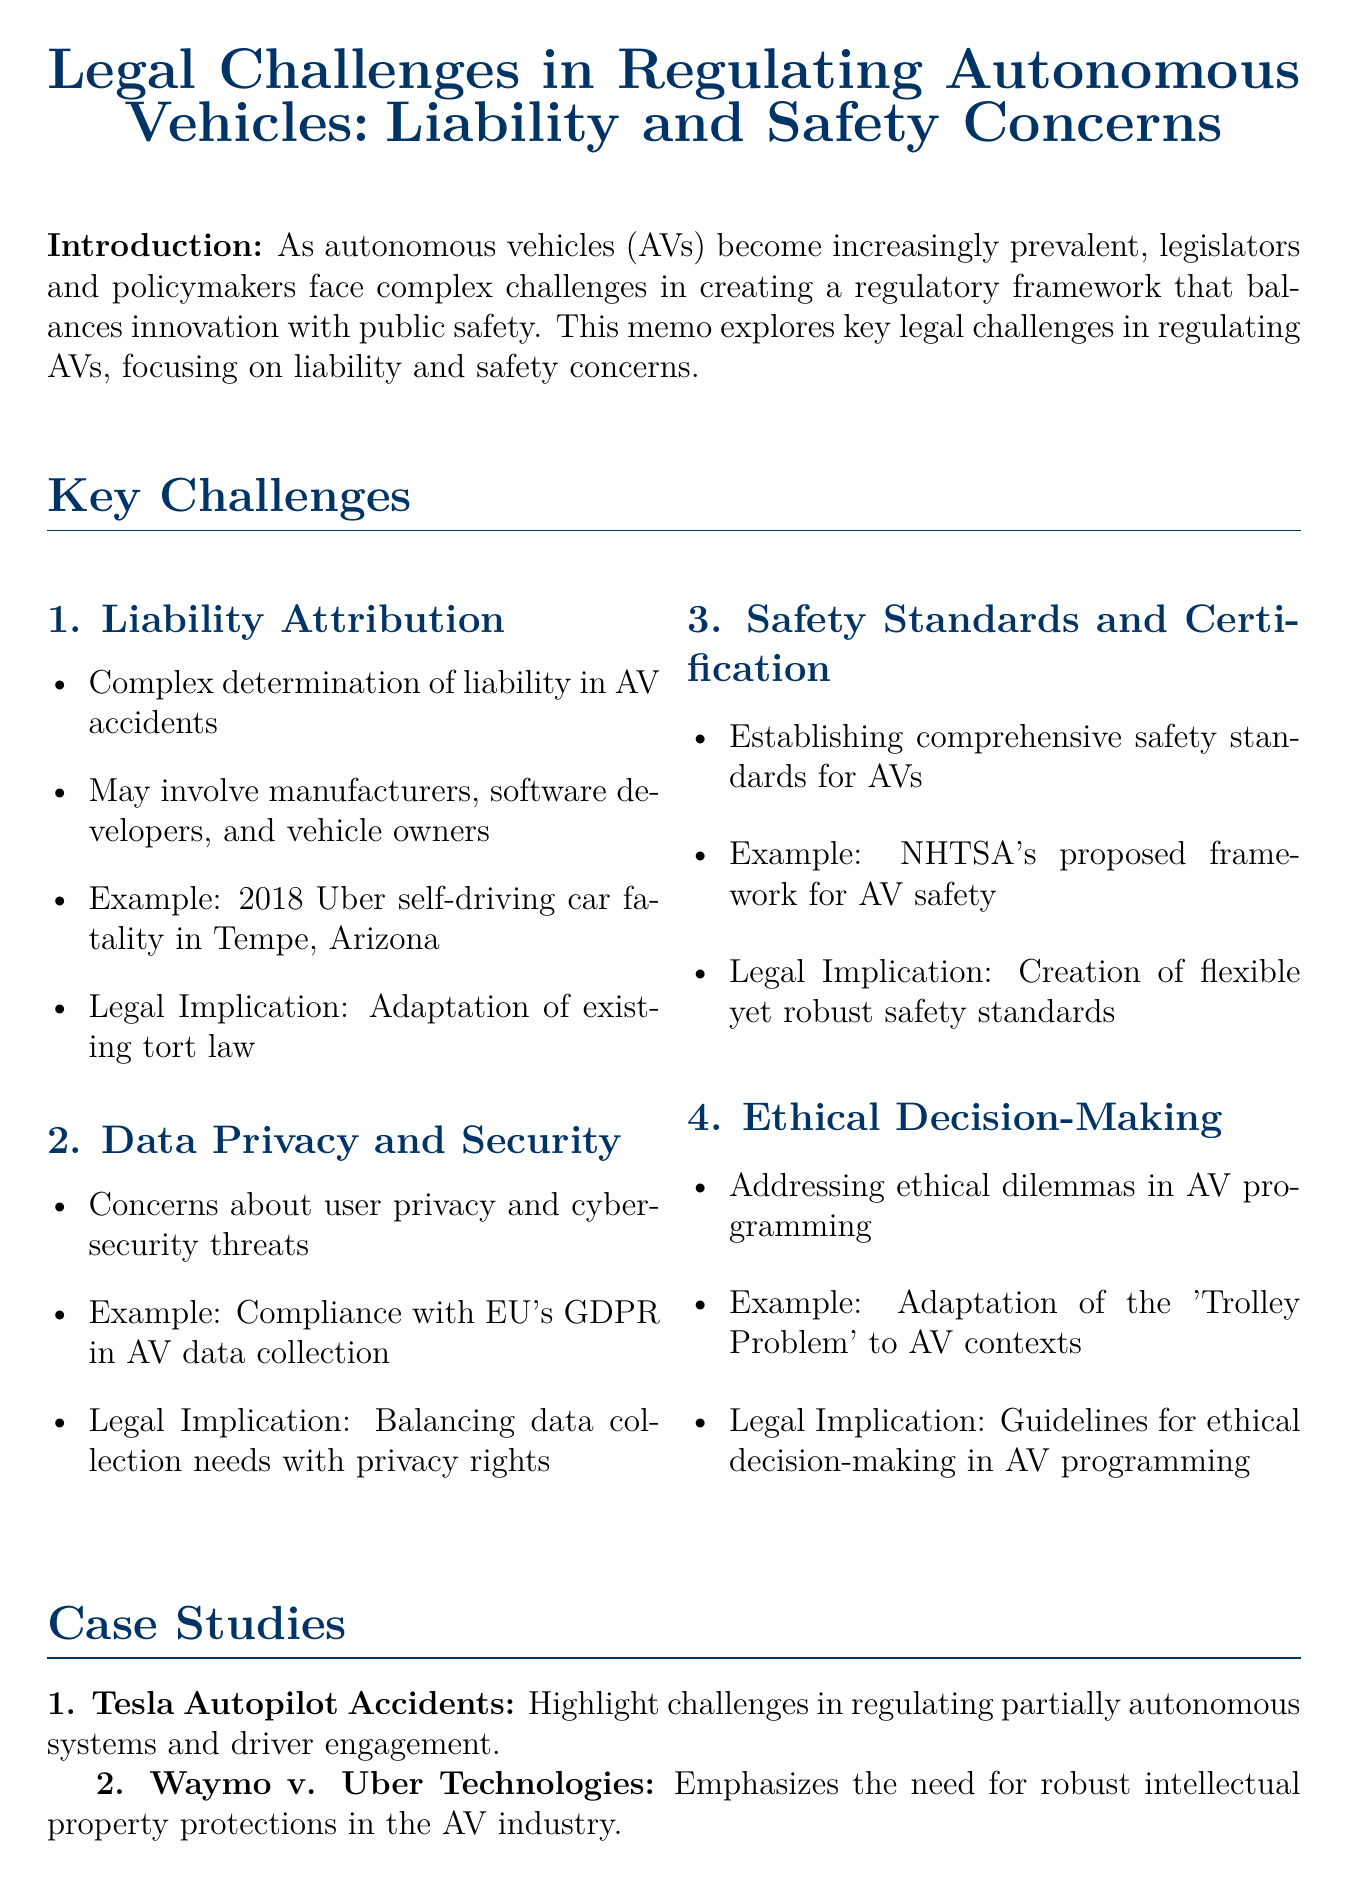What is the title of the memo? The title of the memo is stated at the beginning of the document.
Answer: Legal Challenges in Regulating Autonomous Vehicles: Liability and Safety Concerns What is one example of a legal challenge in regulating AVs? The document lists multiple challenges; one example is provided in the liability attribution section.
Answer: Liability Attribution What year did Germany pass the Autonomous Driving Act? The memo mentions the year of the legislation alongside the country's approach to AV regulation.
Answer: 2021 What significant concern is associated with AV data collection? The memo discusses specific concerns related to data privacy and security in the context of AVs.
Answer: User privacy Which case highlighted the need for robust intellectual property protections in the AV industry? The memo references a specific legal case in the case studies section.
Answer: Waymo v. Uber Technologies What ethical dilemma is mentioned in relation to AV programming? The document discusses a specific ethical problem that arises in autonomous vehicle scenarios.
Answer: Trolley Problem What federal agency proposed a framework for AV safety? The memo includes information about this agency in the safety standards and certification section.
Answer: National Highway Traffic Safety Administration What is the primary focus of this memo? The introduction clearly states the key themes and purpose of the memo.
Answer: Liability and safety concerns 